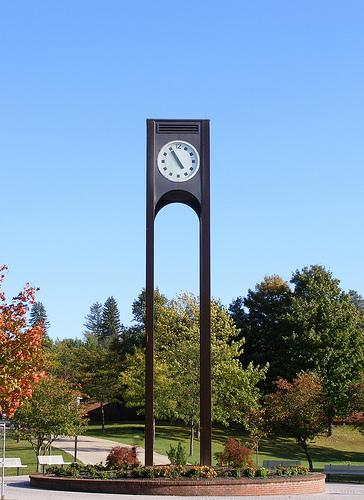Provide a brief overview of the objects interaction in the image. There is a tall clock tower with a large white clock face, surrounded by red and.green trees, a circular brick planter with flowers, white benches, a paved pathway, and a street light behind a tree. How many benches are mentioned in the image and what color are they? There are four benches mentioned in the image, and they are all white. What type of pathway is in the image and what surrounds it? There is a paved, cement walking path in the image, surrounded by green hills, street lights, benches, and trees. What is the planter made of and what is in it? The planter is made of brick and has flowers in it. Describe the general state of the sky in the image. The sky is beautiful, clear, and blue. Mention the presence of any street lights or lamps in the image. There is a street light behind one of the trees, and it is partially obscured by a short green tree. Identify the color of the clock on the tower. The clock on the tower is white. Name the tallest structure in the scene and give a brief description of its features. The tallest structure is the clock tower, which is tall, black, has vents, an arch, and a large white clock face. Count the number of trees mentioned in the image and describe their appearance. There are two trees in the image; one is tall and green, while the other is starting to lose its leaves, which are turning red and yellow. Describe the benches in the park and their current state. There are four white benches in the park, and all of them are empty. How many captions are there for the clock tower? At least eight Where is the street light in relation to the tree? Behind the tree Find the clock on the sign. At position X:156 Y:138 Width:46 Height:46 Is the tree with colorful leaves a small shrub? The tree with red and yellow leaves is described as tall, and losing its leaves as they turn red. It is not mentioned as a small shrub. Is the planter made of wood instead of bricks? No, it's not mentioned in the image. Are the benches green and metallic in the park? The benches in the park are described as white and empty, with no mention of them being green or metallic. Determine the overall sentiment conveyed by the image's subject matter. Positive In the image, what is the notable condition of the sky? Beautiful, clear, and blue Are the flowers in the planter yellow and blue? The flowers in the planter are described as salmon-colored and orange, with no mention of them being yellow or blue. Choose the color of the flowers that are in the bed. Orange and salmon-colored flowers What material is used for the construction of the planter? Brick Count the number of empty benches. Four empty benches What is the color of the clock's hands? Black Comment on the quality of the image. The image quality is high-resolution and well-composed. List the colors of the leaves in the image. Green, red, and yellow Is the bench empty in the background? Yes Which objects are starting to lose their leaves and turning red? Tree How many benches are in the park as seen in the image? Four white benches Describe the appearance of the tall clock tower. Artistic, metallic, dark brown, tall, has an arch, has vents, and large clock on it Identify any anomalies in the image. No visible anomalies Describe the main path seen in the image. Paved pathway, cement walking path down a green hill Identify the shape of the planter in the image. Circular Are the flowers in the planter or outside it? In the planter What type of plants can be seen in the planter? Flowers and bushes 